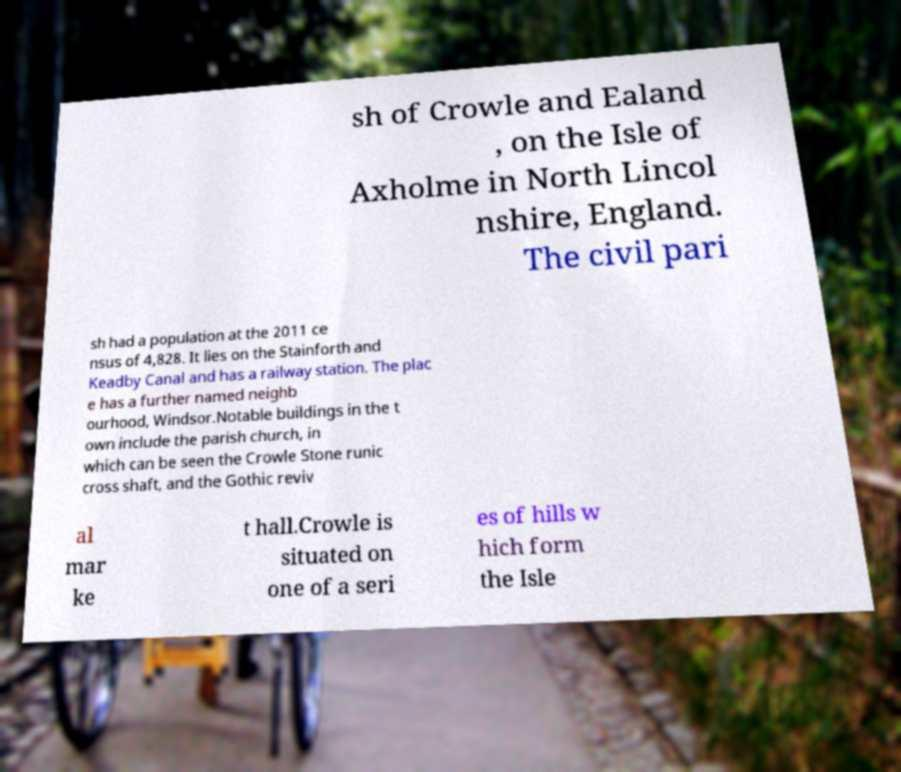Can you accurately transcribe the text from the provided image for me? sh of Crowle and Ealand , on the Isle of Axholme in North Lincol nshire, England. The civil pari sh had a population at the 2011 ce nsus of 4,828. It lies on the Stainforth and Keadby Canal and has a railway station. The plac e has a further named neighb ourhood, Windsor.Notable buildings in the t own include the parish church, in which can be seen the Crowle Stone runic cross shaft, and the Gothic reviv al mar ke t hall.Crowle is situated on one of a seri es of hills w hich form the Isle 